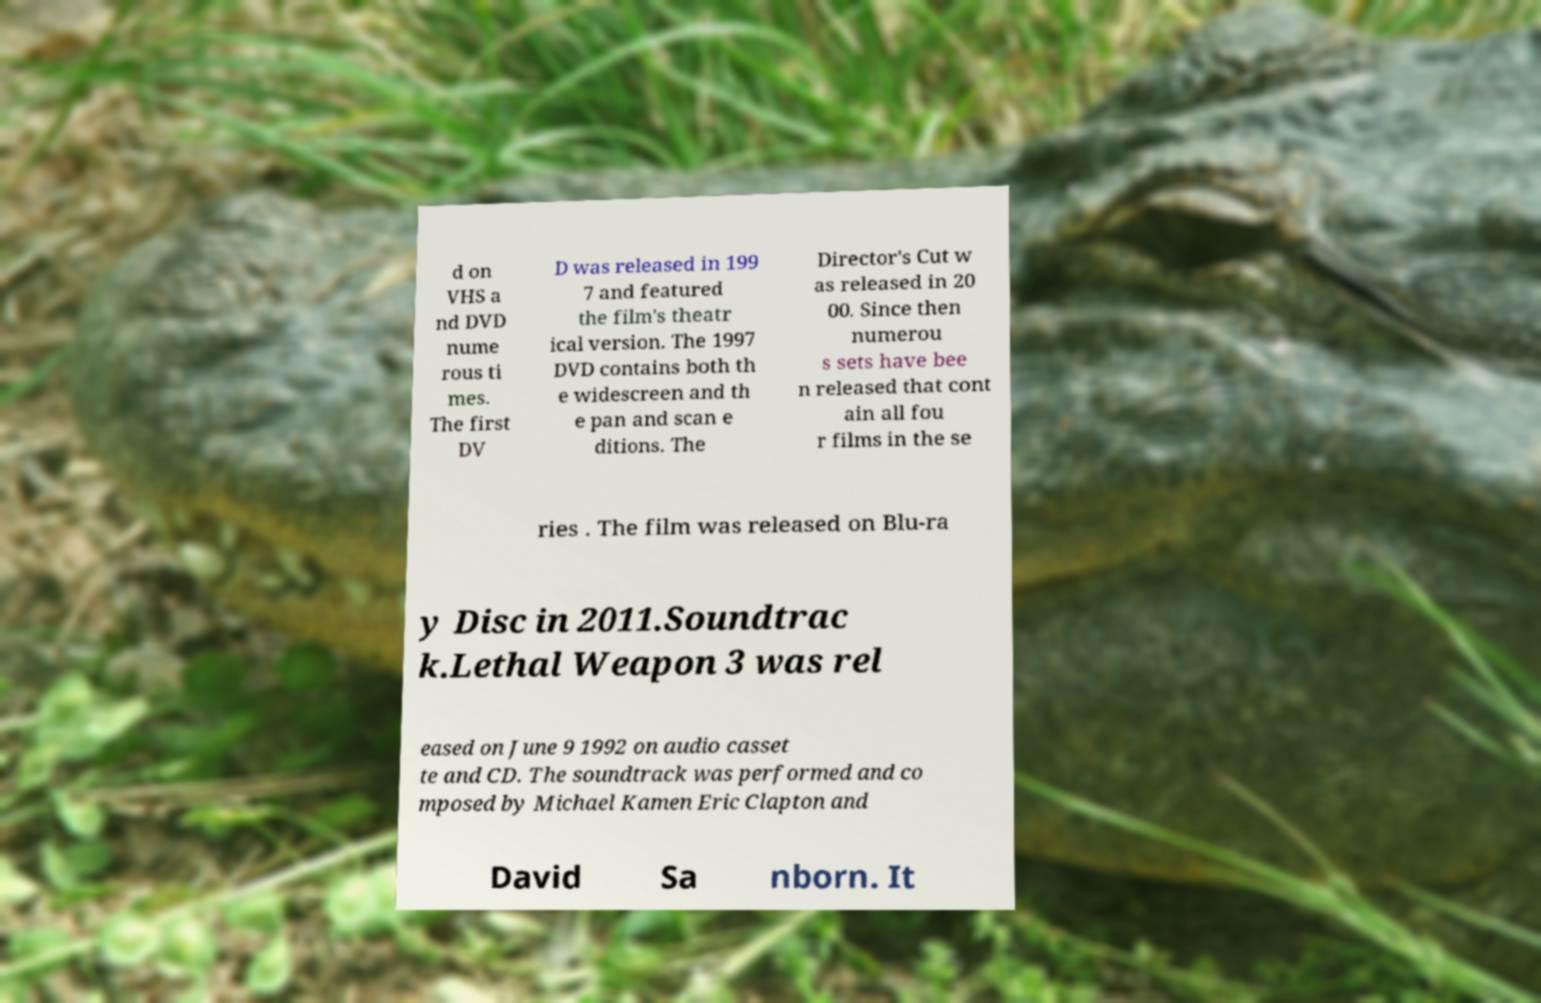Could you assist in decoding the text presented in this image and type it out clearly? d on VHS a nd DVD nume rous ti mes. The first DV D was released in 199 7 and featured the film's theatr ical version. The 1997 DVD contains both th e widescreen and th e pan and scan e ditions. The Director's Cut w as released in 20 00. Since then numerou s sets have bee n released that cont ain all fou r films in the se ries . The film was released on Blu-ra y Disc in 2011.Soundtrac k.Lethal Weapon 3 was rel eased on June 9 1992 on audio casset te and CD. The soundtrack was performed and co mposed by Michael Kamen Eric Clapton and David Sa nborn. It 